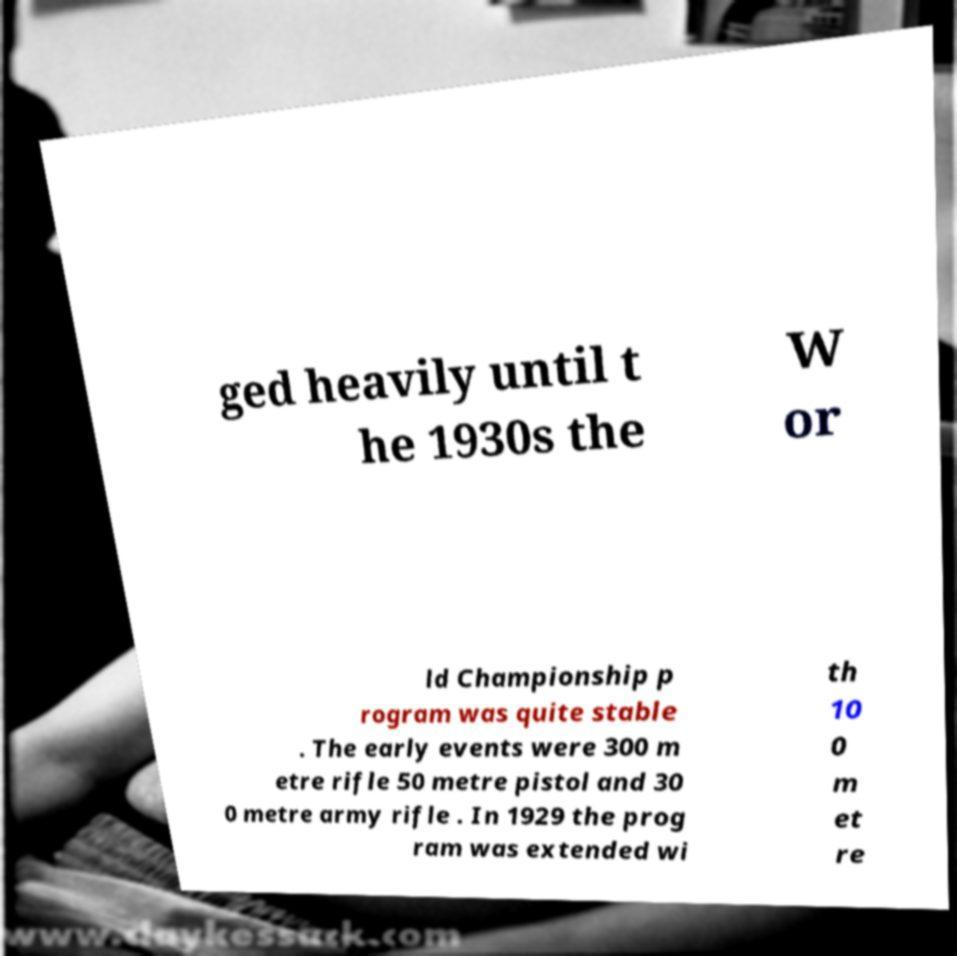Can you accurately transcribe the text from the provided image for me? ged heavily until t he 1930s the W or ld Championship p rogram was quite stable . The early events were 300 m etre rifle 50 metre pistol and 30 0 metre army rifle . In 1929 the prog ram was extended wi th 10 0 m et re 